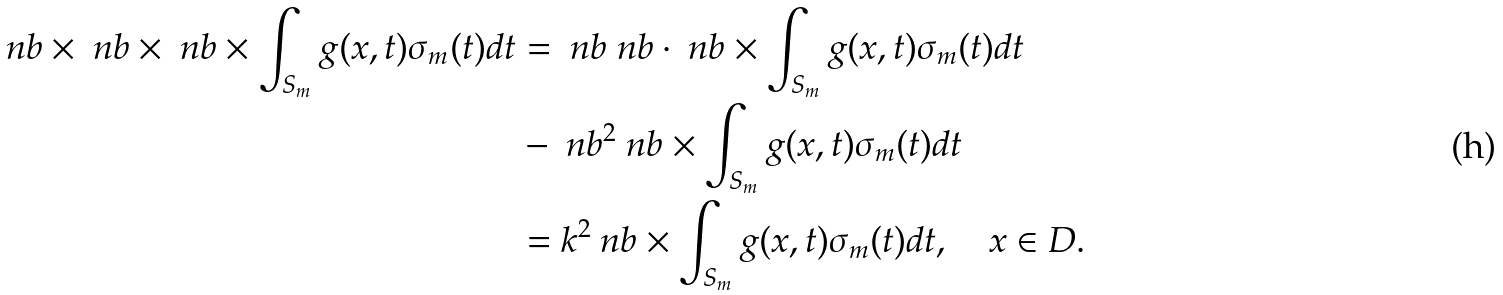Convert formula to latex. <formula><loc_0><loc_0><loc_500><loc_500>\ n b \times \ n b \times \ n b \times \int _ { S _ { m } } g ( x , t ) \sigma _ { m } ( t ) d t & = \ n b \ n b \cdot \ n b \times \int _ { S _ { m } } g ( x , t ) \sigma _ { m } ( t ) d t \\ & - \ n b ^ { 2 } \ n b \times \int _ { S _ { m } } g ( x , t ) \sigma _ { m } ( t ) d t \\ & = k ^ { 2 } \ n b \times \int _ { S _ { m } } g ( x , t ) \sigma _ { m } ( t ) d t , \quad x \in D .</formula> 